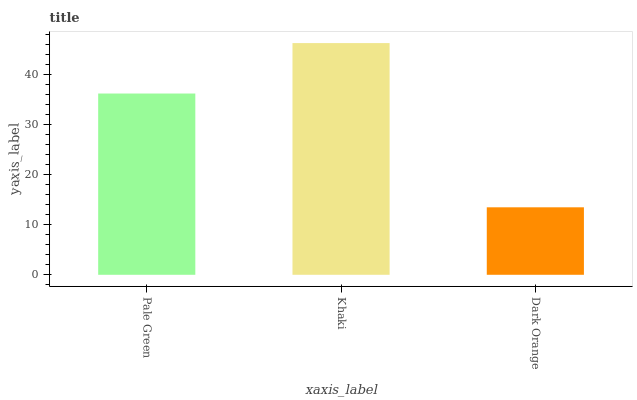Is Khaki the maximum?
Answer yes or no. Yes. Is Khaki the minimum?
Answer yes or no. No. Is Dark Orange the maximum?
Answer yes or no. No. Is Khaki greater than Dark Orange?
Answer yes or no. Yes. Is Dark Orange less than Khaki?
Answer yes or no. Yes. Is Dark Orange greater than Khaki?
Answer yes or no. No. Is Khaki less than Dark Orange?
Answer yes or no. No. Is Pale Green the high median?
Answer yes or no. Yes. Is Pale Green the low median?
Answer yes or no. Yes. Is Khaki the high median?
Answer yes or no. No. Is Dark Orange the low median?
Answer yes or no. No. 